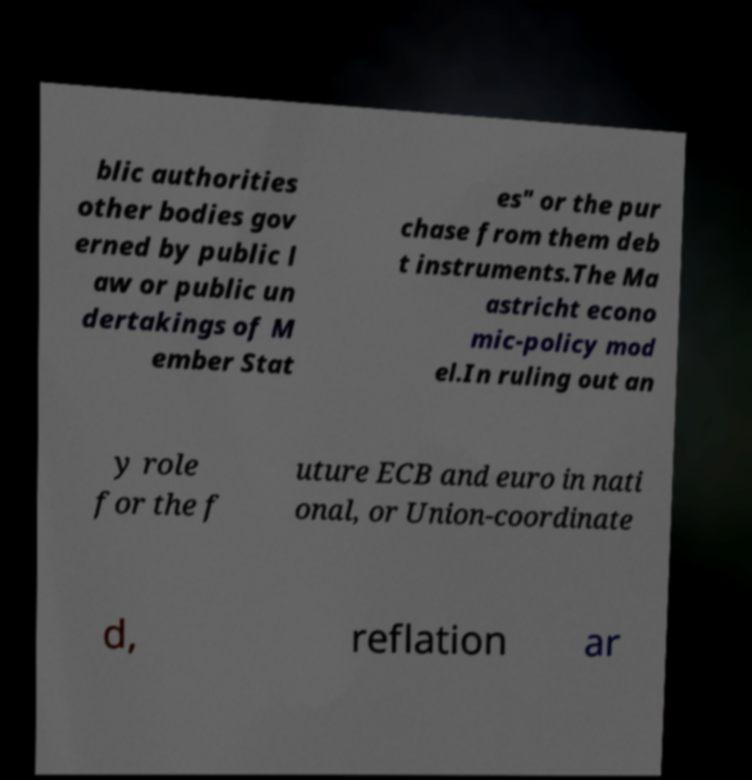Please identify and transcribe the text found in this image. blic authorities other bodies gov erned by public l aw or public un dertakings of M ember Stat es" or the pur chase from them deb t instruments.The Ma astricht econo mic-policy mod el.In ruling out an y role for the f uture ECB and euro in nati onal, or Union-coordinate d, reflation ar 